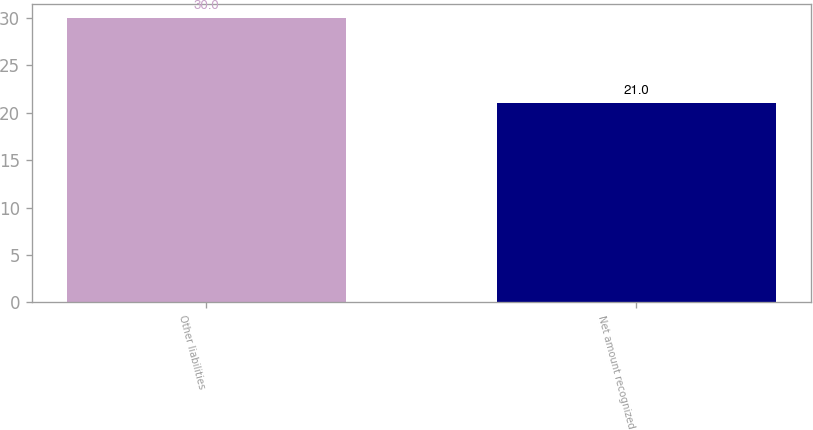Convert chart. <chart><loc_0><loc_0><loc_500><loc_500><bar_chart><fcel>Other liabilities<fcel>Net amount recognized<nl><fcel>30<fcel>21<nl></chart> 